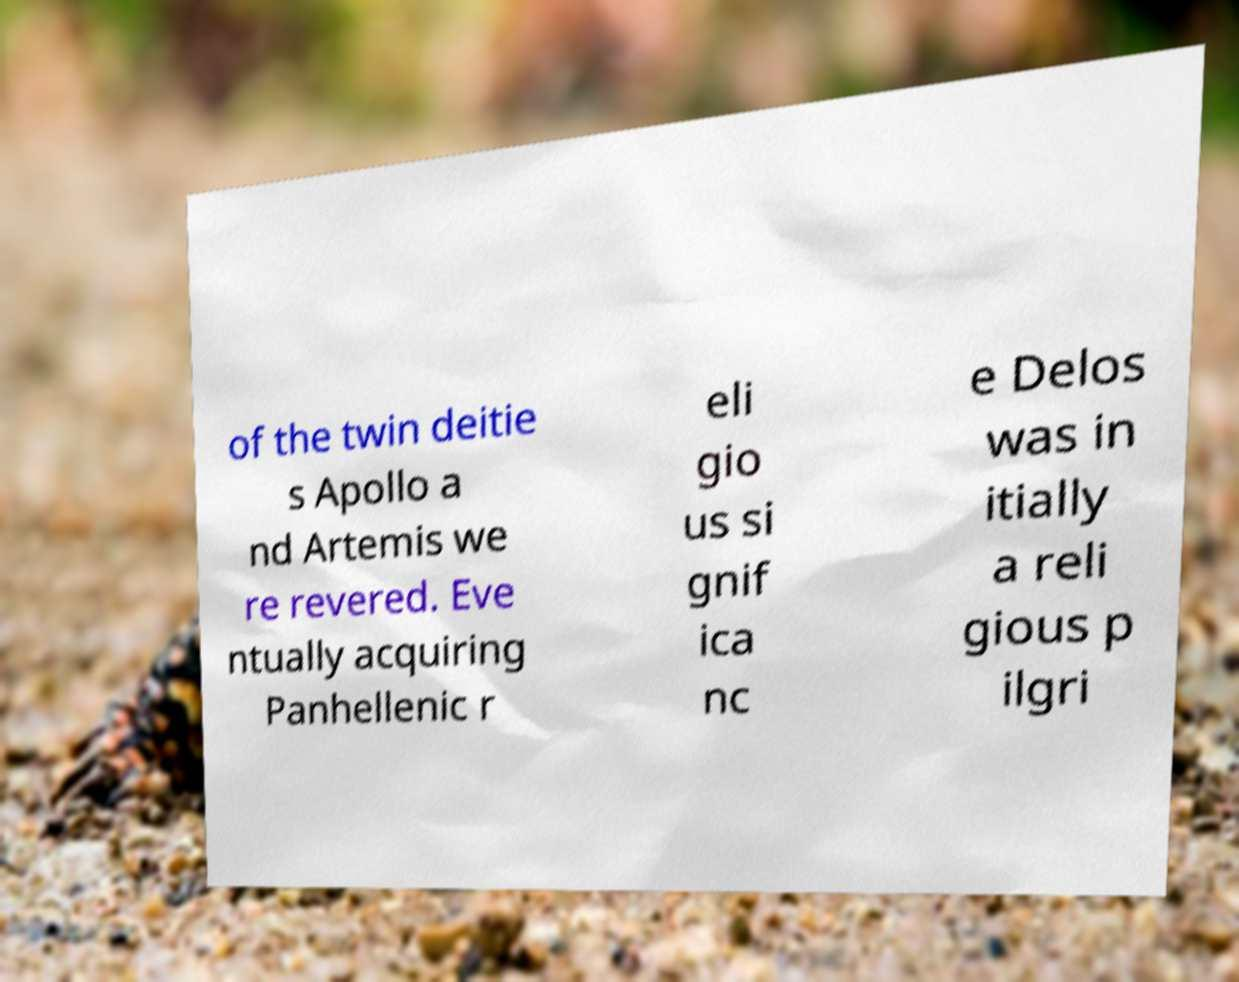Could you assist in decoding the text presented in this image and type it out clearly? of the twin deitie s Apollo a nd Artemis we re revered. Eve ntually acquiring Panhellenic r eli gio us si gnif ica nc e Delos was in itially a reli gious p ilgri 